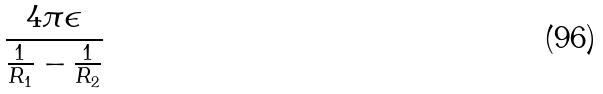<formula> <loc_0><loc_0><loc_500><loc_500>\frac { 4 \pi \epsilon } { \frac { 1 } { R _ { 1 } } - \frac { 1 } { R _ { 2 } } }</formula> 